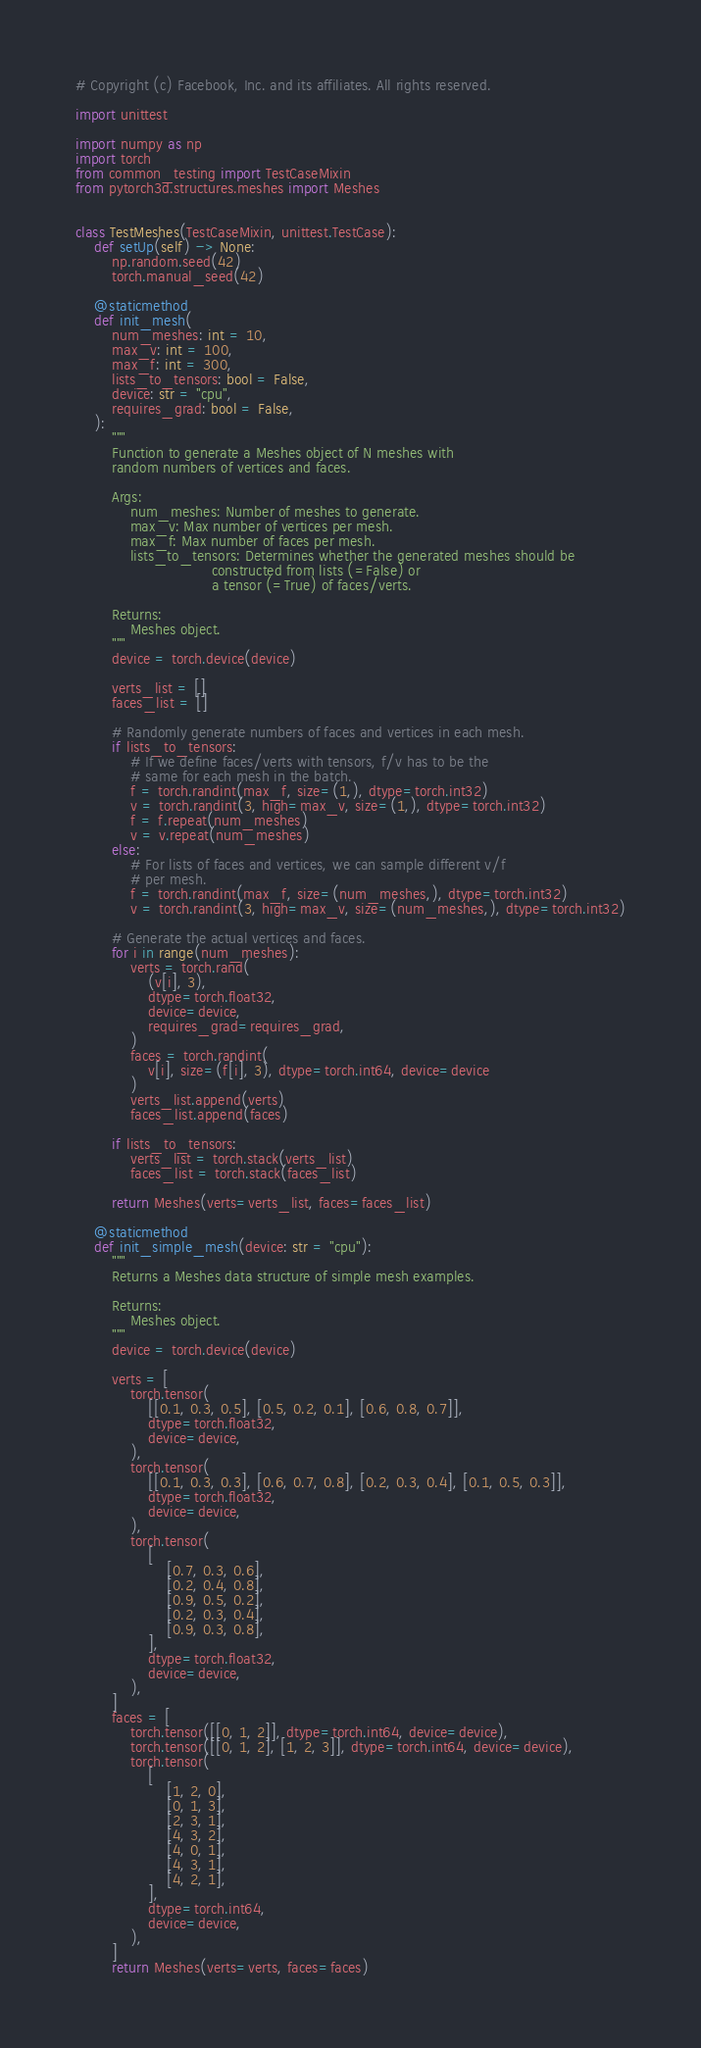<code> <loc_0><loc_0><loc_500><loc_500><_Python_># Copyright (c) Facebook, Inc. and its affiliates. All rights reserved.

import unittest

import numpy as np
import torch
from common_testing import TestCaseMixin
from pytorch3d.structures.meshes import Meshes


class TestMeshes(TestCaseMixin, unittest.TestCase):
    def setUp(self) -> None:
        np.random.seed(42)
        torch.manual_seed(42)

    @staticmethod
    def init_mesh(
        num_meshes: int = 10,
        max_v: int = 100,
        max_f: int = 300,
        lists_to_tensors: bool = False,
        device: str = "cpu",
        requires_grad: bool = False,
    ):
        """
        Function to generate a Meshes object of N meshes with
        random numbers of vertices and faces.

        Args:
            num_meshes: Number of meshes to generate.
            max_v: Max number of vertices per mesh.
            max_f: Max number of faces per mesh.
            lists_to_tensors: Determines whether the generated meshes should be
                              constructed from lists (=False) or
                              a tensor (=True) of faces/verts.

        Returns:
            Meshes object.
        """
        device = torch.device(device)

        verts_list = []
        faces_list = []

        # Randomly generate numbers of faces and vertices in each mesh.
        if lists_to_tensors:
            # If we define faces/verts with tensors, f/v has to be the
            # same for each mesh in the batch.
            f = torch.randint(max_f, size=(1,), dtype=torch.int32)
            v = torch.randint(3, high=max_v, size=(1,), dtype=torch.int32)
            f = f.repeat(num_meshes)
            v = v.repeat(num_meshes)
        else:
            # For lists of faces and vertices, we can sample different v/f
            # per mesh.
            f = torch.randint(max_f, size=(num_meshes,), dtype=torch.int32)
            v = torch.randint(3, high=max_v, size=(num_meshes,), dtype=torch.int32)

        # Generate the actual vertices and faces.
        for i in range(num_meshes):
            verts = torch.rand(
                (v[i], 3),
                dtype=torch.float32,
                device=device,
                requires_grad=requires_grad,
            )
            faces = torch.randint(
                v[i], size=(f[i], 3), dtype=torch.int64, device=device
            )
            verts_list.append(verts)
            faces_list.append(faces)

        if lists_to_tensors:
            verts_list = torch.stack(verts_list)
            faces_list = torch.stack(faces_list)

        return Meshes(verts=verts_list, faces=faces_list)

    @staticmethod
    def init_simple_mesh(device: str = "cpu"):
        """
        Returns a Meshes data structure of simple mesh examples.

        Returns:
            Meshes object.
        """
        device = torch.device(device)

        verts = [
            torch.tensor(
                [[0.1, 0.3, 0.5], [0.5, 0.2, 0.1], [0.6, 0.8, 0.7]],
                dtype=torch.float32,
                device=device,
            ),
            torch.tensor(
                [[0.1, 0.3, 0.3], [0.6, 0.7, 0.8], [0.2, 0.3, 0.4], [0.1, 0.5, 0.3]],
                dtype=torch.float32,
                device=device,
            ),
            torch.tensor(
                [
                    [0.7, 0.3, 0.6],
                    [0.2, 0.4, 0.8],
                    [0.9, 0.5, 0.2],
                    [0.2, 0.3, 0.4],
                    [0.9, 0.3, 0.8],
                ],
                dtype=torch.float32,
                device=device,
            ),
        ]
        faces = [
            torch.tensor([[0, 1, 2]], dtype=torch.int64, device=device),
            torch.tensor([[0, 1, 2], [1, 2, 3]], dtype=torch.int64, device=device),
            torch.tensor(
                [
                    [1, 2, 0],
                    [0, 1, 3],
                    [2, 3, 1],
                    [4, 3, 2],
                    [4, 0, 1],
                    [4, 3, 1],
                    [4, 2, 1],
                ],
                dtype=torch.int64,
                device=device,
            ),
        ]
        return Meshes(verts=verts, faces=faces)
</code> 